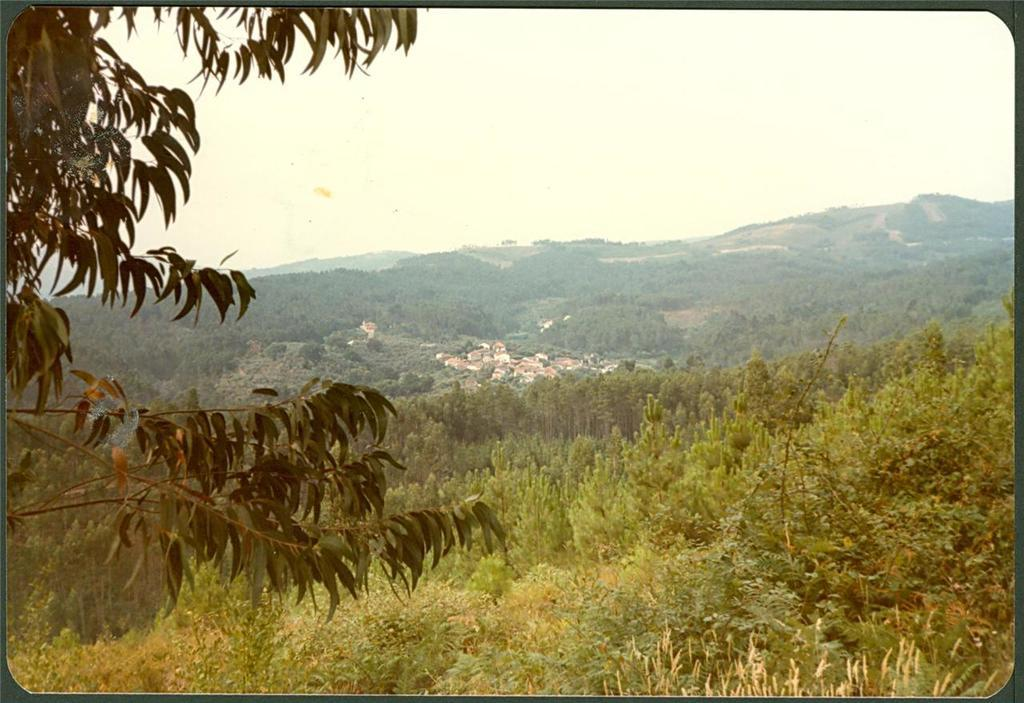What type of natural elements can be seen in the image? There are trees in the image. What type of man-made structures are visible in the image? There are buildings in the image. What is visible at the top of the image? The sky is visible at the top of the image. What type of lace can be seen hanging from the trees in the image? There is no lace present in the image; it features trees and buildings. How many quivers can be seen on the buildings in the image? There are no quivers present in the image; it only features trees and buildings. 